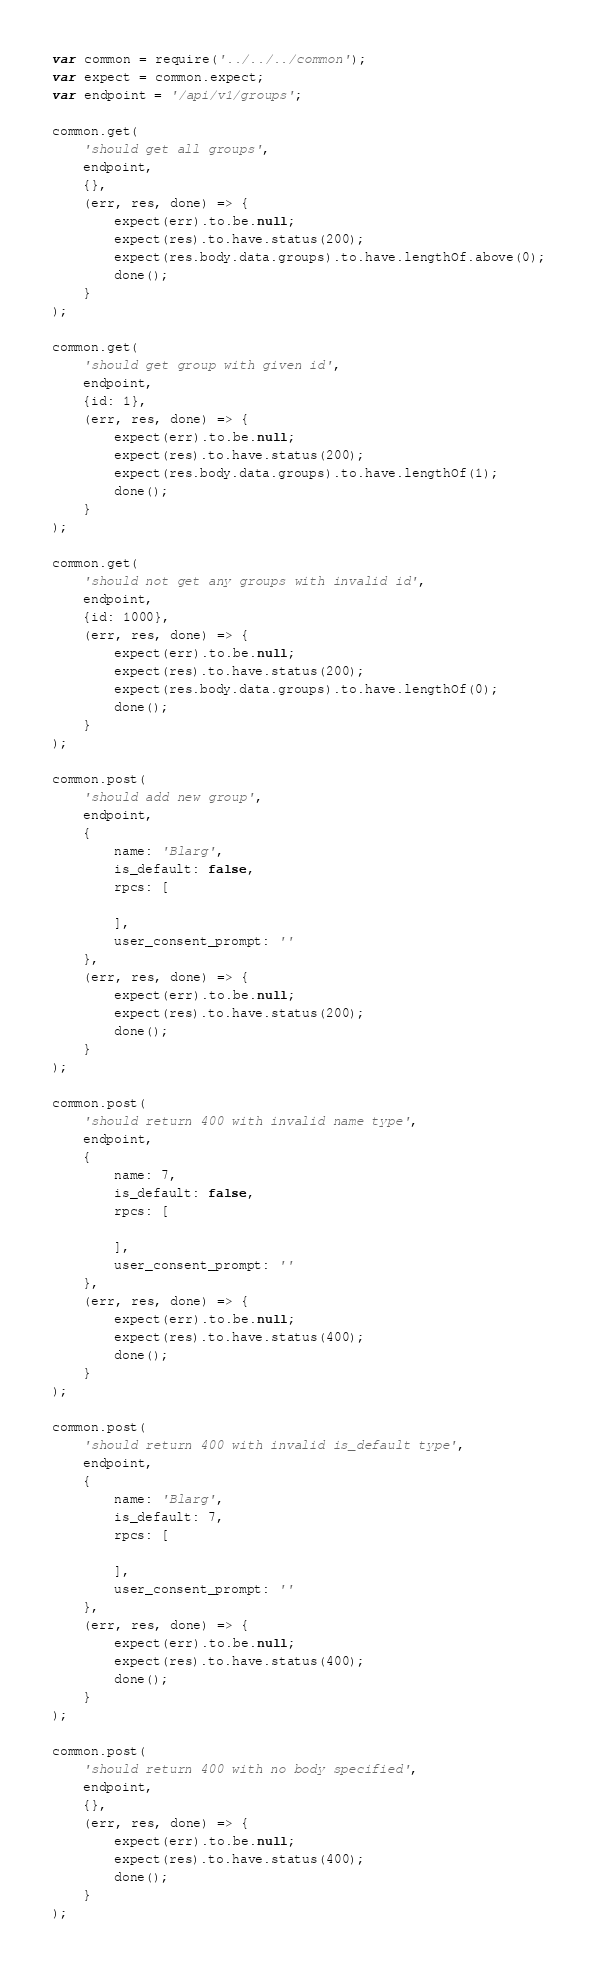<code> <loc_0><loc_0><loc_500><loc_500><_JavaScript_>var common = require('../../../common');
var expect = common.expect;
var endpoint = '/api/v1/groups';

common.get(
    'should get all groups',
    endpoint,
    {},
    (err, res, done) => {
        expect(err).to.be.null;
        expect(res).to.have.status(200);
        expect(res.body.data.groups).to.have.lengthOf.above(0);
        done();
    }
);

common.get(
    'should get group with given id',
    endpoint,
    {id: 1},
    (err, res, done) => {
        expect(err).to.be.null;
        expect(res).to.have.status(200);
        expect(res.body.data.groups).to.have.lengthOf(1);
        done();
    }
);

common.get(
    'should not get any groups with invalid id',
    endpoint,
    {id: 1000},
    (err, res, done) => {
        expect(err).to.be.null;
        expect(res).to.have.status(200);
        expect(res.body.data.groups).to.have.lengthOf(0);
        done();
    }
);

common.post(
    'should add new group',
    endpoint,
    {
        name: 'Blarg',
        is_default: false,
        rpcs: [

        ],
        user_consent_prompt: ''
    },
    (err, res, done) => {
        expect(err).to.be.null;
        expect(res).to.have.status(200);
        done();
    }
);

common.post(
    'should return 400 with invalid name type',
    endpoint,
    {
        name: 7,
        is_default: false,
        rpcs: [

        ],
        user_consent_prompt: ''
    },
    (err, res, done) => {
        expect(err).to.be.null;
        expect(res).to.have.status(400);
        done();
    }
);

common.post(
    'should return 400 with invalid is_default type',
    endpoint,
    {
        name: 'Blarg',
        is_default: 7,
        rpcs: [

        ],
        user_consent_prompt: ''
    },
    (err, res, done) => {
        expect(err).to.be.null;
        expect(res).to.have.status(400);
        done();
    }
);

common.post(
    'should return 400 with no body specified',
    endpoint,
    {},
    (err, res, done) => {
        expect(err).to.be.null;
        expect(res).to.have.status(400);
        done();
    }
);
</code> 